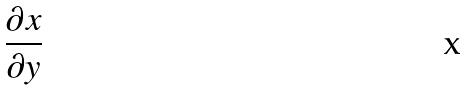<formula> <loc_0><loc_0><loc_500><loc_500>\frac { \partial x } { \partial y }</formula> 